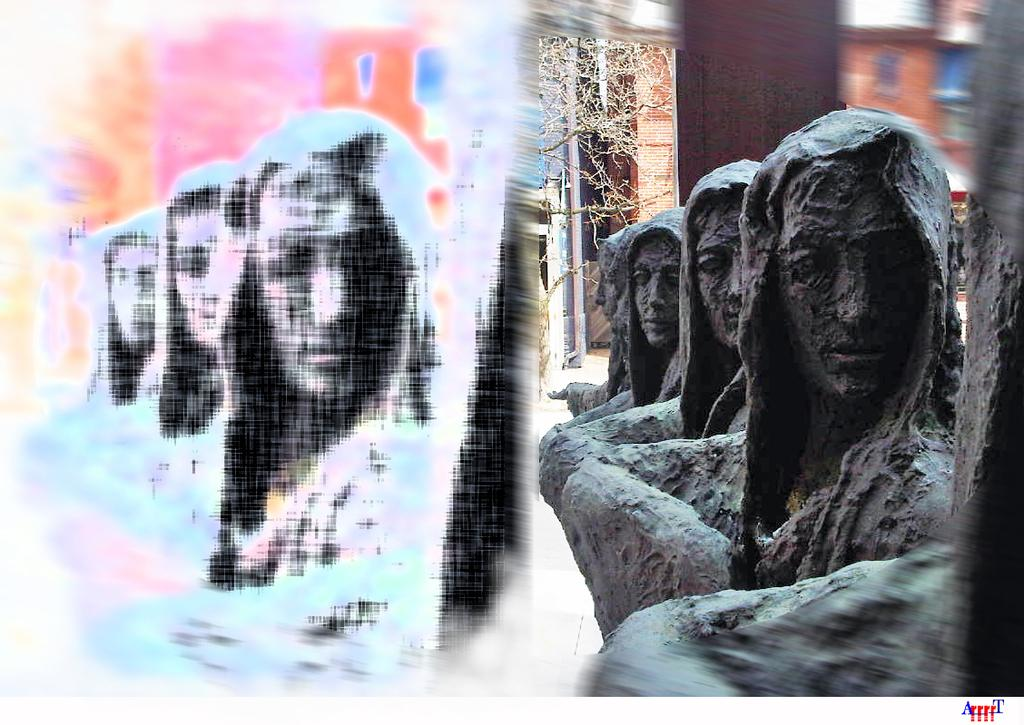What can be seen on the right side of the image? There are statues on the right side of the image. What is visible in the background of the image? There is a building in the background of the image. What type of plant is present in the image? There is a tree in the image. What visual effect is applied to the left side of the image? There is a photo effect on the left side of the image. Can you describe the taste of the soup in the image? There is no soup present in the image, so it is not possible to describe its taste. What part of the body is visible on the left side of the image? There is no body part visible on the left side of the image; the photo effect is applied to the image instead. 